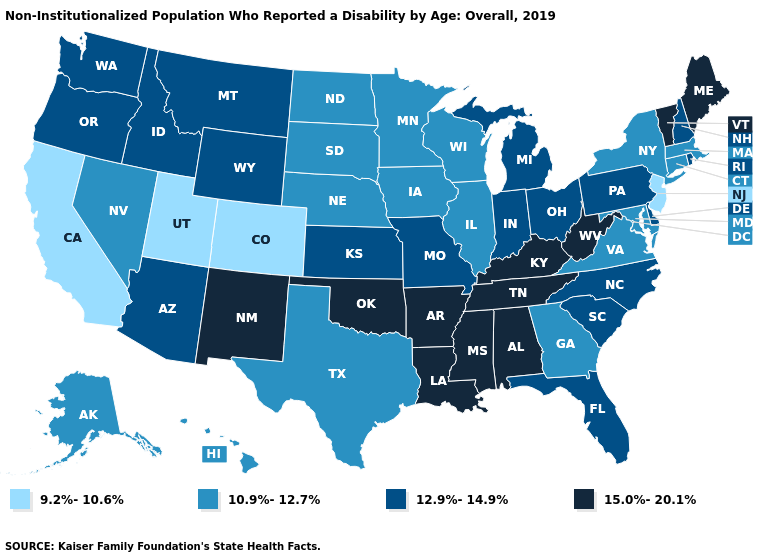What is the value of Minnesota?
Write a very short answer. 10.9%-12.7%. What is the value of Texas?
Quick response, please. 10.9%-12.7%. Name the states that have a value in the range 10.9%-12.7%?
Answer briefly. Alaska, Connecticut, Georgia, Hawaii, Illinois, Iowa, Maryland, Massachusetts, Minnesota, Nebraska, Nevada, New York, North Dakota, South Dakota, Texas, Virginia, Wisconsin. Does Michigan have a lower value than West Virginia?
Write a very short answer. Yes. What is the value of Hawaii?
Concise answer only. 10.9%-12.7%. What is the value of Arkansas?
Short answer required. 15.0%-20.1%. Name the states that have a value in the range 12.9%-14.9%?
Answer briefly. Arizona, Delaware, Florida, Idaho, Indiana, Kansas, Michigan, Missouri, Montana, New Hampshire, North Carolina, Ohio, Oregon, Pennsylvania, Rhode Island, South Carolina, Washington, Wyoming. Does the first symbol in the legend represent the smallest category?
Concise answer only. Yes. Name the states that have a value in the range 12.9%-14.9%?
Give a very brief answer. Arizona, Delaware, Florida, Idaho, Indiana, Kansas, Michigan, Missouri, Montana, New Hampshire, North Carolina, Ohio, Oregon, Pennsylvania, Rhode Island, South Carolina, Washington, Wyoming. How many symbols are there in the legend?
Concise answer only. 4. Does the first symbol in the legend represent the smallest category?
Answer briefly. Yes. What is the value of Tennessee?
Quick response, please. 15.0%-20.1%. Name the states that have a value in the range 15.0%-20.1%?
Write a very short answer. Alabama, Arkansas, Kentucky, Louisiana, Maine, Mississippi, New Mexico, Oklahoma, Tennessee, Vermont, West Virginia. Does the map have missing data?
Be succinct. No. Among the states that border Louisiana , does Texas have the highest value?
Write a very short answer. No. 